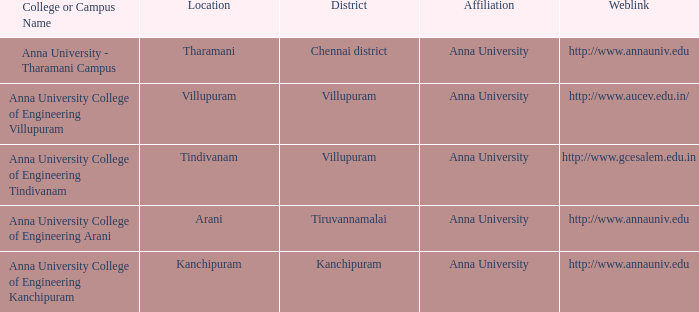Parse the full table. {'header': ['College or Campus Name', 'Location', 'District', 'Affiliation', 'Weblink'], 'rows': [['Anna University - Tharamani Campus', 'Tharamani', 'Chennai district', 'Anna University', 'http://www.annauniv.edu'], ['Anna University College of Engineering Villupuram', 'Villupuram', 'Villupuram', 'Anna University', 'http://www.aucev.edu.in/'], ['Anna University College of Engineering Tindivanam', 'Tindivanam', 'Villupuram', 'Anna University', 'http://www.gcesalem.edu.in'], ['Anna University College of Engineering Arani', 'Arani', 'Tiruvannamalai', 'Anna University', 'http://www.annauniv.edu'], ['Anna University College of Engineering Kanchipuram', 'Kanchipuram', 'Kanchipuram', 'Anna University', 'http://www.annauniv.edu']]} What District has a College or Campus Name of anna university college of engineering kanchipuram? Kanchipuram. 